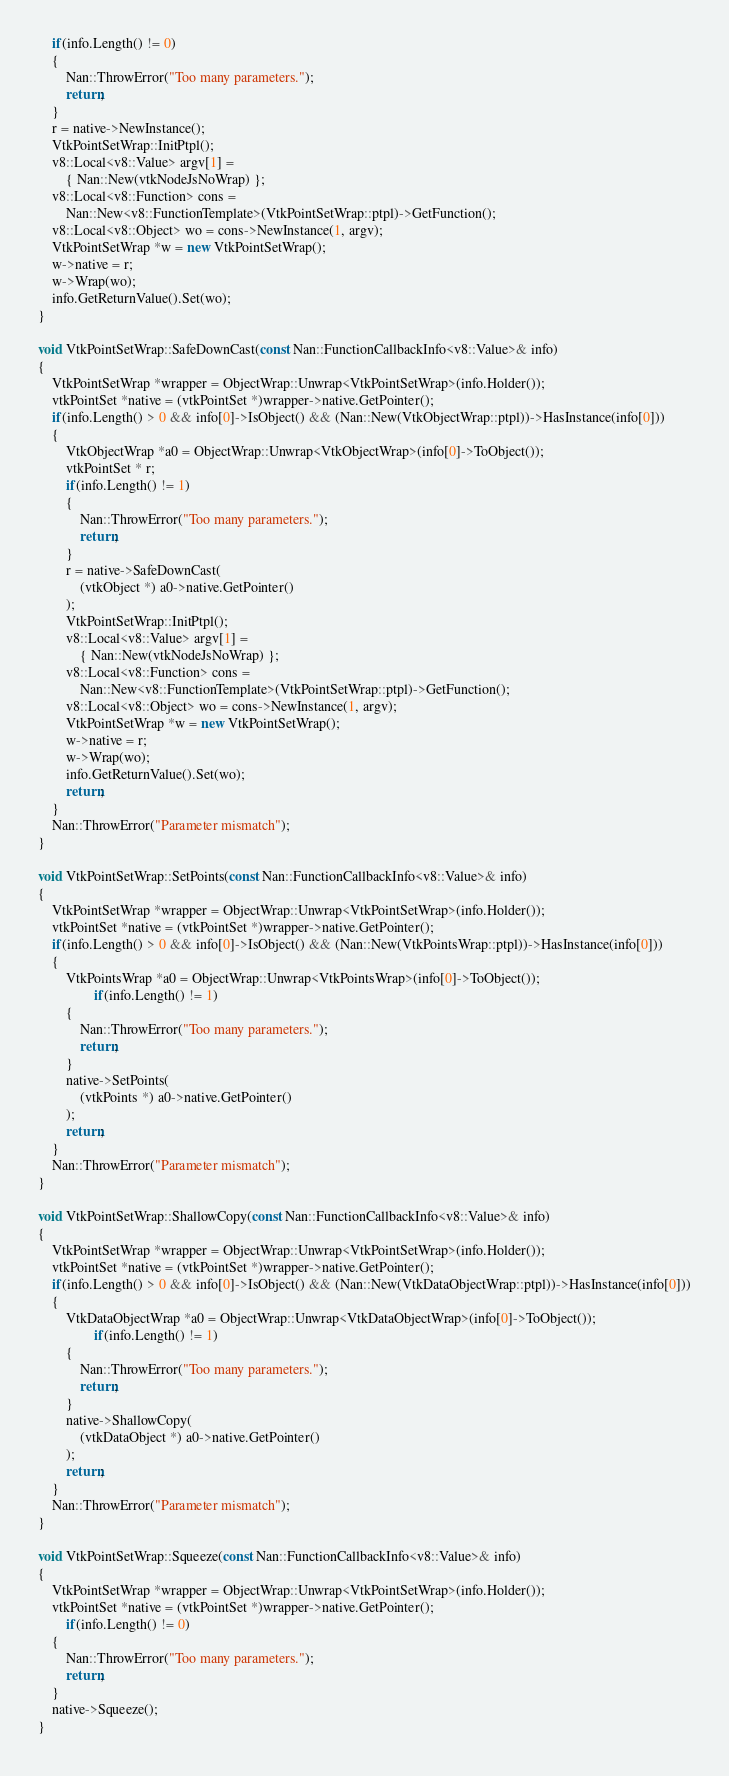Convert code to text. <code><loc_0><loc_0><loc_500><loc_500><_C++_>	if(info.Length() != 0)
	{
		Nan::ThrowError("Too many parameters.");
		return;
	}
	r = native->NewInstance();
	VtkPointSetWrap::InitPtpl();
	v8::Local<v8::Value> argv[1] =
		{ Nan::New(vtkNodeJsNoWrap) };
	v8::Local<v8::Function> cons =
		Nan::New<v8::FunctionTemplate>(VtkPointSetWrap::ptpl)->GetFunction();
	v8::Local<v8::Object> wo = cons->NewInstance(1, argv);
	VtkPointSetWrap *w = new VtkPointSetWrap();
	w->native = r;
	w->Wrap(wo);
	info.GetReturnValue().Set(wo);
}

void VtkPointSetWrap::SafeDownCast(const Nan::FunctionCallbackInfo<v8::Value>& info)
{
	VtkPointSetWrap *wrapper = ObjectWrap::Unwrap<VtkPointSetWrap>(info.Holder());
	vtkPointSet *native = (vtkPointSet *)wrapper->native.GetPointer();
	if(info.Length() > 0 && info[0]->IsObject() && (Nan::New(VtkObjectWrap::ptpl))->HasInstance(info[0]))
	{
		VtkObjectWrap *a0 = ObjectWrap::Unwrap<VtkObjectWrap>(info[0]->ToObject());
		vtkPointSet * r;
		if(info.Length() != 1)
		{
			Nan::ThrowError("Too many parameters.");
			return;
		}
		r = native->SafeDownCast(
			(vtkObject *) a0->native.GetPointer()
		);
		VtkPointSetWrap::InitPtpl();
		v8::Local<v8::Value> argv[1] =
			{ Nan::New(vtkNodeJsNoWrap) };
		v8::Local<v8::Function> cons =
			Nan::New<v8::FunctionTemplate>(VtkPointSetWrap::ptpl)->GetFunction();
		v8::Local<v8::Object> wo = cons->NewInstance(1, argv);
		VtkPointSetWrap *w = new VtkPointSetWrap();
		w->native = r;
		w->Wrap(wo);
		info.GetReturnValue().Set(wo);
		return;
	}
	Nan::ThrowError("Parameter mismatch");
}

void VtkPointSetWrap::SetPoints(const Nan::FunctionCallbackInfo<v8::Value>& info)
{
	VtkPointSetWrap *wrapper = ObjectWrap::Unwrap<VtkPointSetWrap>(info.Holder());
	vtkPointSet *native = (vtkPointSet *)wrapper->native.GetPointer();
	if(info.Length() > 0 && info[0]->IsObject() && (Nan::New(VtkPointsWrap::ptpl))->HasInstance(info[0]))
	{
		VtkPointsWrap *a0 = ObjectWrap::Unwrap<VtkPointsWrap>(info[0]->ToObject());
				if(info.Length() != 1)
		{
			Nan::ThrowError("Too many parameters.");
			return;
		}
		native->SetPoints(
			(vtkPoints *) a0->native.GetPointer()
		);
		return;
	}
	Nan::ThrowError("Parameter mismatch");
}

void VtkPointSetWrap::ShallowCopy(const Nan::FunctionCallbackInfo<v8::Value>& info)
{
	VtkPointSetWrap *wrapper = ObjectWrap::Unwrap<VtkPointSetWrap>(info.Holder());
	vtkPointSet *native = (vtkPointSet *)wrapper->native.GetPointer();
	if(info.Length() > 0 && info[0]->IsObject() && (Nan::New(VtkDataObjectWrap::ptpl))->HasInstance(info[0]))
	{
		VtkDataObjectWrap *a0 = ObjectWrap::Unwrap<VtkDataObjectWrap>(info[0]->ToObject());
				if(info.Length() != 1)
		{
			Nan::ThrowError("Too many parameters.");
			return;
		}
		native->ShallowCopy(
			(vtkDataObject *) a0->native.GetPointer()
		);
		return;
	}
	Nan::ThrowError("Parameter mismatch");
}

void VtkPointSetWrap::Squeeze(const Nan::FunctionCallbackInfo<v8::Value>& info)
{
	VtkPointSetWrap *wrapper = ObjectWrap::Unwrap<VtkPointSetWrap>(info.Holder());
	vtkPointSet *native = (vtkPointSet *)wrapper->native.GetPointer();
		if(info.Length() != 0)
	{
		Nan::ThrowError("Too many parameters.");
		return;
	}
	native->Squeeze();
}

</code> 